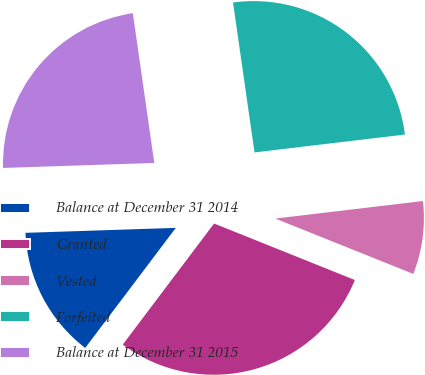Convert chart to OTSL. <chart><loc_0><loc_0><loc_500><loc_500><pie_chart><fcel>Balance at December 31 2014<fcel>Granted<fcel>Vested<fcel>Forfeited<fcel>Balance at December 31 2015<nl><fcel>14.19%<fcel>29.21%<fcel>7.96%<fcel>25.38%<fcel>23.26%<nl></chart> 